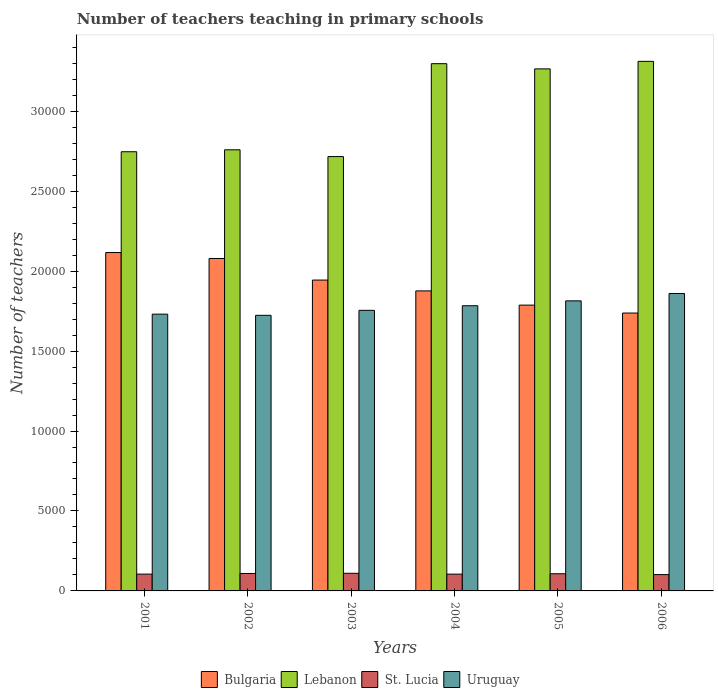How many different coloured bars are there?
Your answer should be compact. 4. Are the number of bars per tick equal to the number of legend labels?
Provide a succinct answer. Yes. In how many cases, is the number of bars for a given year not equal to the number of legend labels?
Provide a short and direct response. 0. What is the number of teachers teaching in primary schools in Lebanon in 2002?
Make the answer very short. 2.76e+04. Across all years, what is the maximum number of teachers teaching in primary schools in Lebanon?
Your response must be concise. 3.31e+04. Across all years, what is the minimum number of teachers teaching in primary schools in Bulgaria?
Your answer should be very brief. 1.74e+04. In which year was the number of teachers teaching in primary schools in St. Lucia minimum?
Keep it short and to the point. 2006. What is the total number of teachers teaching in primary schools in Uruguay in the graph?
Offer a very short reply. 1.07e+05. What is the difference between the number of teachers teaching in primary schools in Lebanon in 2003 and that in 2006?
Make the answer very short. -5954. What is the difference between the number of teachers teaching in primary schools in Bulgaria in 2005 and the number of teachers teaching in primary schools in St. Lucia in 2002?
Give a very brief answer. 1.68e+04. What is the average number of teachers teaching in primary schools in Bulgaria per year?
Your answer should be very brief. 1.92e+04. In the year 2006, what is the difference between the number of teachers teaching in primary schools in St. Lucia and number of teachers teaching in primary schools in Uruguay?
Your answer should be compact. -1.76e+04. In how many years, is the number of teachers teaching in primary schools in Uruguay greater than 29000?
Your answer should be compact. 0. What is the ratio of the number of teachers teaching in primary schools in St. Lucia in 2001 to that in 2003?
Your answer should be very brief. 0.95. Is the number of teachers teaching in primary schools in Bulgaria in 2004 less than that in 2005?
Your answer should be compact. No. Is the difference between the number of teachers teaching in primary schools in St. Lucia in 2003 and 2005 greater than the difference between the number of teachers teaching in primary schools in Uruguay in 2003 and 2005?
Offer a terse response. Yes. What is the difference between the highest and the second highest number of teachers teaching in primary schools in Bulgaria?
Your response must be concise. 372. Is the sum of the number of teachers teaching in primary schools in Lebanon in 2005 and 2006 greater than the maximum number of teachers teaching in primary schools in Bulgaria across all years?
Offer a terse response. Yes. Is it the case that in every year, the sum of the number of teachers teaching in primary schools in St. Lucia and number of teachers teaching in primary schools in Lebanon is greater than the sum of number of teachers teaching in primary schools in Uruguay and number of teachers teaching in primary schools in Bulgaria?
Your answer should be very brief. No. What does the 3rd bar from the left in 2002 represents?
Give a very brief answer. St. Lucia. What does the 2nd bar from the right in 2006 represents?
Make the answer very short. St. Lucia. Is it the case that in every year, the sum of the number of teachers teaching in primary schools in Bulgaria and number of teachers teaching in primary schools in Lebanon is greater than the number of teachers teaching in primary schools in Uruguay?
Keep it short and to the point. Yes. Are all the bars in the graph horizontal?
Offer a very short reply. No. What is the difference between two consecutive major ticks on the Y-axis?
Your answer should be compact. 5000. Does the graph contain any zero values?
Give a very brief answer. No. Where does the legend appear in the graph?
Make the answer very short. Bottom center. How many legend labels are there?
Offer a terse response. 4. How are the legend labels stacked?
Keep it short and to the point. Horizontal. What is the title of the graph?
Offer a very short reply. Number of teachers teaching in primary schools. What is the label or title of the X-axis?
Your response must be concise. Years. What is the label or title of the Y-axis?
Provide a succinct answer. Number of teachers. What is the Number of teachers of Bulgaria in 2001?
Your answer should be compact. 2.12e+04. What is the Number of teachers in Lebanon in 2001?
Your response must be concise. 2.75e+04. What is the Number of teachers in St. Lucia in 2001?
Your response must be concise. 1052. What is the Number of teachers in Uruguay in 2001?
Offer a very short reply. 1.73e+04. What is the Number of teachers in Bulgaria in 2002?
Give a very brief answer. 2.08e+04. What is the Number of teachers of Lebanon in 2002?
Offer a very short reply. 2.76e+04. What is the Number of teachers of St. Lucia in 2002?
Provide a short and direct response. 1091. What is the Number of teachers of Uruguay in 2002?
Offer a very short reply. 1.72e+04. What is the Number of teachers of Bulgaria in 2003?
Provide a short and direct response. 1.94e+04. What is the Number of teachers of Lebanon in 2003?
Keep it short and to the point. 2.72e+04. What is the Number of teachers in St. Lucia in 2003?
Ensure brevity in your answer.  1103. What is the Number of teachers in Uruguay in 2003?
Your answer should be very brief. 1.75e+04. What is the Number of teachers in Bulgaria in 2004?
Keep it short and to the point. 1.88e+04. What is the Number of teachers in Lebanon in 2004?
Offer a very short reply. 3.30e+04. What is the Number of teachers of St. Lucia in 2004?
Offer a very short reply. 1050. What is the Number of teachers of Uruguay in 2004?
Provide a short and direct response. 1.78e+04. What is the Number of teachers of Bulgaria in 2005?
Your answer should be very brief. 1.79e+04. What is the Number of teachers in Lebanon in 2005?
Your response must be concise. 3.26e+04. What is the Number of teachers of St. Lucia in 2005?
Offer a terse response. 1073. What is the Number of teachers in Uruguay in 2005?
Your answer should be compact. 1.81e+04. What is the Number of teachers in Bulgaria in 2006?
Make the answer very short. 1.74e+04. What is the Number of teachers in Lebanon in 2006?
Offer a very short reply. 3.31e+04. What is the Number of teachers of St. Lucia in 2006?
Provide a succinct answer. 1022. What is the Number of teachers of Uruguay in 2006?
Provide a succinct answer. 1.86e+04. Across all years, what is the maximum Number of teachers in Bulgaria?
Ensure brevity in your answer.  2.12e+04. Across all years, what is the maximum Number of teachers of Lebanon?
Ensure brevity in your answer.  3.31e+04. Across all years, what is the maximum Number of teachers of St. Lucia?
Give a very brief answer. 1103. Across all years, what is the maximum Number of teachers of Uruguay?
Keep it short and to the point. 1.86e+04. Across all years, what is the minimum Number of teachers in Bulgaria?
Your answer should be compact. 1.74e+04. Across all years, what is the minimum Number of teachers in Lebanon?
Provide a succinct answer. 2.72e+04. Across all years, what is the minimum Number of teachers of St. Lucia?
Provide a short and direct response. 1022. Across all years, what is the minimum Number of teachers of Uruguay?
Your answer should be very brief. 1.72e+04. What is the total Number of teachers of Bulgaria in the graph?
Keep it short and to the point. 1.15e+05. What is the total Number of teachers of Lebanon in the graph?
Offer a terse response. 1.81e+05. What is the total Number of teachers in St. Lucia in the graph?
Give a very brief answer. 6391. What is the total Number of teachers of Uruguay in the graph?
Make the answer very short. 1.07e+05. What is the difference between the Number of teachers in Bulgaria in 2001 and that in 2002?
Provide a succinct answer. 372. What is the difference between the Number of teachers of Lebanon in 2001 and that in 2002?
Offer a terse response. -122. What is the difference between the Number of teachers in St. Lucia in 2001 and that in 2002?
Give a very brief answer. -39. What is the difference between the Number of teachers of Bulgaria in 2001 and that in 2003?
Your response must be concise. 1722. What is the difference between the Number of teachers in Lebanon in 2001 and that in 2003?
Your answer should be very brief. 301. What is the difference between the Number of teachers in St. Lucia in 2001 and that in 2003?
Offer a very short reply. -51. What is the difference between the Number of teachers in Uruguay in 2001 and that in 2003?
Give a very brief answer. -240. What is the difference between the Number of teachers of Bulgaria in 2001 and that in 2004?
Make the answer very short. 2399. What is the difference between the Number of teachers in Lebanon in 2001 and that in 2004?
Offer a very short reply. -5508. What is the difference between the Number of teachers of Uruguay in 2001 and that in 2004?
Ensure brevity in your answer.  -527. What is the difference between the Number of teachers of Bulgaria in 2001 and that in 2005?
Provide a short and direct response. 3288. What is the difference between the Number of teachers in Lebanon in 2001 and that in 2005?
Your answer should be compact. -5182. What is the difference between the Number of teachers in St. Lucia in 2001 and that in 2005?
Give a very brief answer. -21. What is the difference between the Number of teachers in Uruguay in 2001 and that in 2005?
Your response must be concise. -832. What is the difference between the Number of teachers in Bulgaria in 2001 and that in 2006?
Your answer should be compact. 3783. What is the difference between the Number of teachers in Lebanon in 2001 and that in 2006?
Offer a very short reply. -5653. What is the difference between the Number of teachers in St. Lucia in 2001 and that in 2006?
Give a very brief answer. 30. What is the difference between the Number of teachers of Uruguay in 2001 and that in 2006?
Offer a terse response. -1293. What is the difference between the Number of teachers in Bulgaria in 2002 and that in 2003?
Offer a terse response. 1350. What is the difference between the Number of teachers in Lebanon in 2002 and that in 2003?
Your answer should be compact. 423. What is the difference between the Number of teachers in St. Lucia in 2002 and that in 2003?
Offer a terse response. -12. What is the difference between the Number of teachers of Uruguay in 2002 and that in 2003?
Offer a terse response. -312. What is the difference between the Number of teachers of Bulgaria in 2002 and that in 2004?
Offer a terse response. 2027. What is the difference between the Number of teachers of Lebanon in 2002 and that in 2004?
Your answer should be very brief. -5386. What is the difference between the Number of teachers of Uruguay in 2002 and that in 2004?
Offer a terse response. -599. What is the difference between the Number of teachers in Bulgaria in 2002 and that in 2005?
Your answer should be compact. 2916. What is the difference between the Number of teachers of Lebanon in 2002 and that in 2005?
Your response must be concise. -5060. What is the difference between the Number of teachers of Uruguay in 2002 and that in 2005?
Ensure brevity in your answer.  -904. What is the difference between the Number of teachers in Bulgaria in 2002 and that in 2006?
Offer a very short reply. 3411. What is the difference between the Number of teachers in Lebanon in 2002 and that in 2006?
Make the answer very short. -5531. What is the difference between the Number of teachers in St. Lucia in 2002 and that in 2006?
Your answer should be compact. 69. What is the difference between the Number of teachers in Uruguay in 2002 and that in 2006?
Your answer should be compact. -1365. What is the difference between the Number of teachers in Bulgaria in 2003 and that in 2004?
Keep it short and to the point. 677. What is the difference between the Number of teachers in Lebanon in 2003 and that in 2004?
Your response must be concise. -5809. What is the difference between the Number of teachers in St. Lucia in 2003 and that in 2004?
Provide a succinct answer. 53. What is the difference between the Number of teachers in Uruguay in 2003 and that in 2004?
Provide a short and direct response. -287. What is the difference between the Number of teachers of Bulgaria in 2003 and that in 2005?
Your response must be concise. 1566. What is the difference between the Number of teachers of Lebanon in 2003 and that in 2005?
Ensure brevity in your answer.  -5483. What is the difference between the Number of teachers in Uruguay in 2003 and that in 2005?
Provide a succinct answer. -592. What is the difference between the Number of teachers of Bulgaria in 2003 and that in 2006?
Your response must be concise. 2061. What is the difference between the Number of teachers in Lebanon in 2003 and that in 2006?
Offer a very short reply. -5954. What is the difference between the Number of teachers in St. Lucia in 2003 and that in 2006?
Make the answer very short. 81. What is the difference between the Number of teachers in Uruguay in 2003 and that in 2006?
Your response must be concise. -1053. What is the difference between the Number of teachers of Bulgaria in 2004 and that in 2005?
Offer a very short reply. 889. What is the difference between the Number of teachers in Lebanon in 2004 and that in 2005?
Offer a terse response. 326. What is the difference between the Number of teachers in St. Lucia in 2004 and that in 2005?
Offer a very short reply. -23. What is the difference between the Number of teachers in Uruguay in 2004 and that in 2005?
Ensure brevity in your answer.  -305. What is the difference between the Number of teachers in Bulgaria in 2004 and that in 2006?
Offer a very short reply. 1384. What is the difference between the Number of teachers of Lebanon in 2004 and that in 2006?
Your response must be concise. -145. What is the difference between the Number of teachers of Uruguay in 2004 and that in 2006?
Your answer should be very brief. -766. What is the difference between the Number of teachers in Bulgaria in 2005 and that in 2006?
Keep it short and to the point. 495. What is the difference between the Number of teachers in Lebanon in 2005 and that in 2006?
Provide a succinct answer. -471. What is the difference between the Number of teachers in St. Lucia in 2005 and that in 2006?
Ensure brevity in your answer.  51. What is the difference between the Number of teachers of Uruguay in 2005 and that in 2006?
Give a very brief answer. -461. What is the difference between the Number of teachers of Bulgaria in 2001 and the Number of teachers of Lebanon in 2002?
Make the answer very short. -6425. What is the difference between the Number of teachers in Bulgaria in 2001 and the Number of teachers in St. Lucia in 2002?
Provide a succinct answer. 2.01e+04. What is the difference between the Number of teachers in Bulgaria in 2001 and the Number of teachers in Uruguay in 2002?
Make the answer very short. 3926. What is the difference between the Number of teachers in Lebanon in 2001 and the Number of teachers in St. Lucia in 2002?
Your answer should be compact. 2.64e+04. What is the difference between the Number of teachers in Lebanon in 2001 and the Number of teachers in Uruguay in 2002?
Offer a very short reply. 1.02e+04. What is the difference between the Number of teachers of St. Lucia in 2001 and the Number of teachers of Uruguay in 2002?
Your answer should be very brief. -1.62e+04. What is the difference between the Number of teachers in Bulgaria in 2001 and the Number of teachers in Lebanon in 2003?
Provide a succinct answer. -6002. What is the difference between the Number of teachers in Bulgaria in 2001 and the Number of teachers in St. Lucia in 2003?
Your answer should be compact. 2.01e+04. What is the difference between the Number of teachers of Bulgaria in 2001 and the Number of teachers of Uruguay in 2003?
Your answer should be very brief. 3614. What is the difference between the Number of teachers in Lebanon in 2001 and the Number of teachers in St. Lucia in 2003?
Offer a terse response. 2.64e+04. What is the difference between the Number of teachers of Lebanon in 2001 and the Number of teachers of Uruguay in 2003?
Keep it short and to the point. 9917. What is the difference between the Number of teachers in St. Lucia in 2001 and the Number of teachers in Uruguay in 2003?
Your answer should be compact. -1.65e+04. What is the difference between the Number of teachers in Bulgaria in 2001 and the Number of teachers in Lebanon in 2004?
Your answer should be compact. -1.18e+04. What is the difference between the Number of teachers of Bulgaria in 2001 and the Number of teachers of St. Lucia in 2004?
Your answer should be very brief. 2.01e+04. What is the difference between the Number of teachers in Bulgaria in 2001 and the Number of teachers in Uruguay in 2004?
Your answer should be very brief. 3327. What is the difference between the Number of teachers of Lebanon in 2001 and the Number of teachers of St. Lucia in 2004?
Keep it short and to the point. 2.64e+04. What is the difference between the Number of teachers of Lebanon in 2001 and the Number of teachers of Uruguay in 2004?
Your response must be concise. 9630. What is the difference between the Number of teachers of St. Lucia in 2001 and the Number of teachers of Uruguay in 2004?
Give a very brief answer. -1.68e+04. What is the difference between the Number of teachers in Bulgaria in 2001 and the Number of teachers in Lebanon in 2005?
Provide a succinct answer. -1.15e+04. What is the difference between the Number of teachers in Bulgaria in 2001 and the Number of teachers in St. Lucia in 2005?
Your response must be concise. 2.01e+04. What is the difference between the Number of teachers of Bulgaria in 2001 and the Number of teachers of Uruguay in 2005?
Keep it short and to the point. 3022. What is the difference between the Number of teachers in Lebanon in 2001 and the Number of teachers in St. Lucia in 2005?
Provide a short and direct response. 2.64e+04. What is the difference between the Number of teachers in Lebanon in 2001 and the Number of teachers in Uruguay in 2005?
Make the answer very short. 9325. What is the difference between the Number of teachers in St. Lucia in 2001 and the Number of teachers in Uruguay in 2005?
Provide a succinct answer. -1.71e+04. What is the difference between the Number of teachers of Bulgaria in 2001 and the Number of teachers of Lebanon in 2006?
Provide a succinct answer. -1.20e+04. What is the difference between the Number of teachers of Bulgaria in 2001 and the Number of teachers of St. Lucia in 2006?
Make the answer very short. 2.01e+04. What is the difference between the Number of teachers of Bulgaria in 2001 and the Number of teachers of Uruguay in 2006?
Your answer should be compact. 2561. What is the difference between the Number of teachers of Lebanon in 2001 and the Number of teachers of St. Lucia in 2006?
Provide a short and direct response. 2.64e+04. What is the difference between the Number of teachers in Lebanon in 2001 and the Number of teachers in Uruguay in 2006?
Keep it short and to the point. 8864. What is the difference between the Number of teachers in St. Lucia in 2001 and the Number of teachers in Uruguay in 2006?
Provide a short and direct response. -1.75e+04. What is the difference between the Number of teachers in Bulgaria in 2002 and the Number of teachers in Lebanon in 2003?
Provide a succinct answer. -6374. What is the difference between the Number of teachers in Bulgaria in 2002 and the Number of teachers in St. Lucia in 2003?
Ensure brevity in your answer.  1.97e+04. What is the difference between the Number of teachers of Bulgaria in 2002 and the Number of teachers of Uruguay in 2003?
Keep it short and to the point. 3242. What is the difference between the Number of teachers in Lebanon in 2002 and the Number of teachers in St. Lucia in 2003?
Give a very brief answer. 2.65e+04. What is the difference between the Number of teachers in Lebanon in 2002 and the Number of teachers in Uruguay in 2003?
Offer a terse response. 1.00e+04. What is the difference between the Number of teachers in St. Lucia in 2002 and the Number of teachers in Uruguay in 2003?
Your answer should be compact. -1.65e+04. What is the difference between the Number of teachers of Bulgaria in 2002 and the Number of teachers of Lebanon in 2004?
Offer a terse response. -1.22e+04. What is the difference between the Number of teachers in Bulgaria in 2002 and the Number of teachers in St. Lucia in 2004?
Make the answer very short. 1.97e+04. What is the difference between the Number of teachers of Bulgaria in 2002 and the Number of teachers of Uruguay in 2004?
Provide a succinct answer. 2955. What is the difference between the Number of teachers of Lebanon in 2002 and the Number of teachers of St. Lucia in 2004?
Your answer should be very brief. 2.65e+04. What is the difference between the Number of teachers of Lebanon in 2002 and the Number of teachers of Uruguay in 2004?
Give a very brief answer. 9752. What is the difference between the Number of teachers of St. Lucia in 2002 and the Number of teachers of Uruguay in 2004?
Keep it short and to the point. -1.67e+04. What is the difference between the Number of teachers in Bulgaria in 2002 and the Number of teachers in Lebanon in 2005?
Keep it short and to the point. -1.19e+04. What is the difference between the Number of teachers in Bulgaria in 2002 and the Number of teachers in St. Lucia in 2005?
Provide a succinct answer. 1.97e+04. What is the difference between the Number of teachers of Bulgaria in 2002 and the Number of teachers of Uruguay in 2005?
Your answer should be very brief. 2650. What is the difference between the Number of teachers in Lebanon in 2002 and the Number of teachers in St. Lucia in 2005?
Offer a terse response. 2.65e+04. What is the difference between the Number of teachers in Lebanon in 2002 and the Number of teachers in Uruguay in 2005?
Provide a succinct answer. 9447. What is the difference between the Number of teachers of St. Lucia in 2002 and the Number of teachers of Uruguay in 2005?
Provide a short and direct response. -1.70e+04. What is the difference between the Number of teachers in Bulgaria in 2002 and the Number of teachers in Lebanon in 2006?
Ensure brevity in your answer.  -1.23e+04. What is the difference between the Number of teachers of Bulgaria in 2002 and the Number of teachers of St. Lucia in 2006?
Offer a very short reply. 1.98e+04. What is the difference between the Number of teachers of Bulgaria in 2002 and the Number of teachers of Uruguay in 2006?
Offer a terse response. 2189. What is the difference between the Number of teachers of Lebanon in 2002 and the Number of teachers of St. Lucia in 2006?
Give a very brief answer. 2.66e+04. What is the difference between the Number of teachers in Lebanon in 2002 and the Number of teachers in Uruguay in 2006?
Your answer should be very brief. 8986. What is the difference between the Number of teachers of St. Lucia in 2002 and the Number of teachers of Uruguay in 2006?
Ensure brevity in your answer.  -1.75e+04. What is the difference between the Number of teachers in Bulgaria in 2003 and the Number of teachers in Lebanon in 2004?
Provide a short and direct response. -1.35e+04. What is the difference between the Number of teachers of Bulgaria in 2003 and the Number of teachers of St. Lucia in 2004?
Provide a succinct answer. 1.84e+04. What is the difference between the Number of teachers in Bulgaria in 2003 and the Number of teachers in Uruguay in 2004?
Your response must be concise. 1605. What is the difference between the Number of teachers of Lebanon in 2003 and the Number of teachers of St. Lucia in 2004?
Give a very brief answer. 2.61e+04. What is the difference between the Number of teachers of Lebanon in 2003 and the Number of teachers of Uruguay in 2004?
Give a very brief answer. 9329. What is the difference between the Number of teachers in St. Lucia in 2003 and the Number of teachers in Uruguay in 2004?
Your answer should be very brief. -1.67e+04. What is the difference between the Number of teachers of Bulgaria in 2003 and the Number of teachers of Lebanon in 2005?
Give a very brief answer. -1.32e+04. What is the difference between the Number of teachers in Bulgaria in 2003 and the Number of teachers in St. Lucia in 2005?
Offer a very short reply. 1.84e+04. What is the difference between the Number of teachers of Bulgaria in 2003 and the Number of teachers of Uruguay in 2005?
Provide a short and direct response. 1300. What is the difference between the Number of teachers of Lebanon in 2003 and the Number of teachers of St. Lucia in 2005?
Offer a very short reply. 2.61e+04. What is the difference between the Number of teachers of Lebanon in 2003 and the Number of teachers of Uruguay in 2005?
Provide a succinct answer. 9024. What is the difference between the Number of teachers in St. Lucia in 2003 and the Number of teachers in Uruguay in 2005?
Offer a terse response. -1.70e+04. What is the difference between the Number of teachers in Bulgaria in 2003 and the Number of teachers in Lebanon in 2006?
Provide a succinct answer. -1.37e+04. What is the difference between the Number of teachers in Bulgaria in 2003 and the Number of teachers in St. Lucia in 2006?
Your answer should be very brief. 1.84e+04. What is the difference between the Number of teachers in Bulgaria in 2003 and the Number of teachers in Uruguay in 2006?
Make the answer very short. 839. What is the difference between the Number of teachers of Lebanon in 2003 and the Number of teachers of St. Lucia in 2006?
Your response must be concise. 2.61e+04. What is the difference between the Number of teachers in Lebanon in 2003 and the Number of teachers in Uruguay in 2006?
Your answer should be compact. 8563. What is the difference between the Number of teachers in St. Lucia in 2003 and the Number of teachers in Uruguay in 2006?
Your response must be concise. -1.75e+04. What is the difference between the Number of teachers of Bulgaria in 2004 and the Number of teachers of Lebanon in 2005?
Make the answer very short. -1.39e+04. What is the difference between the Number of teachers of Bulgaria in 2004 and the Number of teachers of St. Lucia in 2005?
Offer a terse response. 1.77e+04. What is the difference between the Number of teachers of Bulgaria in 2004 and the Number of teachers of Uruguay in 2005?
Your answer should be very brief. 623. What is the difference between the Number of teachers of Lebanon in 2004 and the Number of teachers of St. Lucia in 2005?
Provide a succinct answer. 3.19e+04. What is the difference between the Number of teachers of Lebanon in 2004 and the Number of teachers of Uruguay in 2005?
Offer a very short reply. 1.48e+04. What is the difference between the Number of teachers in St. Lucia in 2004 and the Number of teachers in Uruguay in 2005?
Offer a very short reply. -1.71e+04. What is the difference between the Number of teachers in Bulgaria in 2004 and the Number of teachers in Lebanon in 2006?
Your answer should be very brief. -1.44e+04. What is the difference between the Number of teachers in Bulgaria in 2004 and the Number of teachers in St. Lucia in 2006?
Your response must be concise. 1.77e+04. What is the difference between the Number of teachers of Bulgaria in 2004 and the Number of teachers of Uruguay in 2006?
Make the answer very short. 162. What is the difference between the Number of teachers of Lebanon in 2004 and the Number of teachers of St. Lucia in 2006?
Keep it short and to the point. 3.20e+04. What is the difference between the Number of teachers of Lebanon in 2004 and the Number of teachers of Uruguay in 2006?
Offer a very short reply. 1.44e+04. What is the difference between the Number of teachers in St. Lucia in 2004 and the Number of teachers in Uruguay in 2006?
Keep it short and to the point. -1.76e+04. What is the difference between the Number of teachers in Bulgaria in 2005 and the Number of teachers in Lebanon in 2006?
Offer a very short reply. -1.52e+04. What is the difference between the Number of teachers in Bulgaria in 2005 and the Number of teachers in St. Lucia in 2006?
Your answer should be compact. 1.69e+04. What is the difference between the Number of teachers in Bulgaria in 2005 and the Number of teachers in Uruguay in 2006?
Provide a succinct answer. -727. What is the difference between the Number of teachers of Lebanon in 2005 and the Number of teachers of St. Lucia in 2006?
Offer a very short reply. 3.16e+04. What is the difference between the Number of teachers in Lebanon in 2005 and the Number of teachers in Uruguay in 2006?
Keep it short and to the point. 1.40e+04. What is the difference between the Number of teachers of St. Lucia in 2005 and the Number of teachers of Uruguay in 2006?
Provide a short and direct response. -1.75e+04. What is the average Number of teachers in Bulgaria per year?
Your answer should be compact. 1.92e+04. What is the average Number of teachers in Lebanon per year?
Your answer should be compact. 3.02e+04. What is the average Number of teachers in St. Lucia per year?
Your answer should be very brief. 1065.17. What is the average Number of teachers in Uruguay per year?
Provide a succinct answer. 1.78e+04. In the year 2001, what is the difference between the Number of teachers in Bulgaria and Number of teachers in Lebanon?
Offer a terse response. -6303. In the year 2001, what is the difference between the Number of teachers of Bulgaria and Number of teachers of St. Lucia?
Provide a short and direct response. 2.01e+04. In the year 2001, what is the difference between the Number of teachers in Bulgaria and Number of teachers in Uruguay?
Offer a very short reply. 3854. In the year 2001, what is the difference between the Number of teachers in Lebanon and Number of teachers in St. Lucia?
Provide a succinct answer. 2.64e+04. In the year 2001, what is the difference between the Number of teachers of Lebanon and Number of teachers of Uruguay?
Give a very brief answer. 1.02e+04. In the year 2001, what is the difference between the Number of teachers in St. Lucia and Number of teachers in Uruguay?
Ensure brevity in your answer.  -1.63e+04. In the year 2002, what is the difference between the Number of teachers in Bulgaria and Number of teachers in Lebanon?
Give a very brief answer. -6797. In the year 2002, what is the difference between the Number of teachers in Bulgaria and Number of teachers in St. Lucia?
Your response must be concise. 1.97e+04. In the year 2002, what is the difference between the Number of teachers of Bulgaria and Number of teachers of Uruguay?
Your response must be concise. 3554. In the year 2002, what is the difference between the Number of teachers in Lebanon and Number of teachers in St. Lucia?
Offer a terse response. 2.65e+04. In the year 2002, what is the difference between the Number of teachers in Lebanon and Number of teachers in Uruguay?
Offer a terse response. 1.04e+04. In the year 2002, what is the difference between the Number of teachers of St. Lucia and Number of teachers of Uruguay?
Your answer should be very brief. -1.61e+04. In the year 2003, what is the difference between the Number of teachers in Bulgaria and Number of teachers in Lebanon?
Make the answer very short. -7724. In the year 2003, what is the difference between the Number of teachers of Bulgaria and Number of teachers of St. Lucia?
Ensure brevity in your answer.  1.83e+04. In the year 2003, what is the difference between the Number of teachers of Bulgaria and Number of teachers of Uruguay?
Offer a terse response. 1892. In the year 2003, what is the difference between the Number of teachers in Lebanon and Number of teachers in St. Lucia?
Provide a short and direct response. 2.61e+04. In the year 2003, what is the difference between the Number of teachers in Lebanon and Number of teachers in Uruguay?
Provide a short and direct response. 9616. In the year 2003, what is the difference between the Number of teachers in St. Lucia and Number of teachers in Uruguay?
Ensure brevity in your answer.  -1.64e+04. In the year 2004, what is the difference between the Number of teachers of Bulgaria and Number of teachers of Lebanon?
Make the answer very short. -1.42e+04. In the year 2004, what is the difference between the Number of teachers of Bulgaria and Number of teachers of St. Lucia?
Ensure brevity in your answer.  1.77e+04. In the year 2004, what is the difference between the Number of teachers of Bulgaria and Number of teachers of Uruguay?
Provide a short and direct response. 928. In the year 2004, what is the difference between the Number of teachers in Lebanon and Number of teachers in St. Lucia?
Keep it short and to the point. 3.19e+04. In the year 2004, what is the difference between the Number of teachers of Lebanon and Number of teachers of Uruguay?
Make the answer very short. 1.51e+04. In the year 2004, what is the difference between the Number of teachers in St. Lucia and Number of teachers in Uruguay?
Offer a very short reply. -1.68e+04. In the year 2005, what is the difference between the Number of teachers of Bulgaria and Number of teachers of Lebanon?
Give a very brief answer. -1.48e+04. In the year 2005, what is the difference between the Number of teachers in Bulgaria and Number of teachers in St. Lucia?
Offer a terse response. 1.68e+04. In the year 2005, what is the difference between the Number of teachers in Bulgaria and Number of teachers in Uruguay?
Your answer should be very brief. -266. In the year 2005, what is the difference between the Number of teachers of Lebanon and Number of teachers of St. Lucia?
Provide a short and direct response. 3.16e+04. In the year 2005, what is the difference between the Number of teachers in Lebanon and Number of teachers in Uruguay?
Make the answer very short. 1.45e+04. In the year 2005, what is the difference between the Number of teachers of St. Lucia and Number of teachers of Uruguay?
Give a very brief answer. -1.71e+04. In the year 2006, what is the difference between the Number of teachers of Bulgaria and Number of teachers of Lebanon?
Provide a succinct answer. -1.57e+04. In the year 2006, what is the difference between the Number of teachers of Bulgaria and Number of teachers of St. Lucia?
Give a very brief answer. 1.64e+04. In the year 2006, what is the difference between the Number of teachers of Bulgaria and Number of teachers of Uruguay?
Give a very brief answer. -1222. In the year 2006, what is the difference between the Number of teachers in Lebanon and Number of teachers in St. Lucia?
Offer a terse response. 3.21e+04. In the year 2006, what is the difference between the Number of teachers in Lebanon and Number of teachers in Uruguay?
Offer a terse response. 1.45e+04. In the year 2006, what is the difference between the Number of teachers in St. Lucia and Number of teachers in Uruguay?
Make the answer very short. -1.76e+04. What is the ratio of the Number of teachers in Bulgaria in 2001 to that in 2002?
Ensure brevity in your answer.  1.02. What is the ratio of the Number of teachers of St. Lucia in 2001 to that in 2002?
Ensure brevity in your answer.  0.96. What is the ratio of the Number of teachers in Uruguay in 2001 to that in 2002?
Provide a succinct answer. 1. What is the ratio of the Number of teachers in Bulgaria in 2001 to that in 2003?
Make the answer very short. 1.09. What is the ratio of the Number of teachers of Lebanon in 2001 to that in 2003?
Make the answer very short. 1.01. What is the ratio of the Number of teachers in St. Lucia in 2001 to that in 2003?
Provide a succinct answer. 0.95. What is the ratio of the Number of teachers of Uruguay in 2001 to that in 2003?
Your response must be concise. 0.99. What is the ratio of the Number of teachers of Bulgaria in 2001 to that in 2004?
Ensure brevity in your answer.  1.13. What is the ratio of the Number of teachers in Lebanon in 2001 to that in 2004?
Your answer should be very brief. 0.83. What is the ratio of the Number of teachers in St. Lucia in 2001 to that in 2004?
Give a very brief answer. 1. What is the ratio of the Number of teachers in Uruguay in 2001 to that in 2004?
Offer a terse response. 0.97. What is the ratio of the Number of teachers in Bulgaria in 2001 to that in 2005?
Your answer should be compact. 1.18. What is the ratio of the Number of teachers of Lebanon in 2001 to that in 2005?
Offer a terse response. 0.84. What is the ratio of the Number of teachers in St. Lucia in 2001 to that in 2005?
Give a very brief answer. 0.98. What is the ratio of the Number of teachers in Uruguay in 2001 to that in 2005?
Ensure brevity in your answer.  0.95. What is the ratio of the Number of teachers in Bulgaria in 2001 to that in 2006?
Provide a succinct answer. 1.22. What is the ratio of the Number of teachers of Lebanon in 2001 to that in 2006?
Offer a very short reply. 0.83. What is the ratio of the Number of teachers of St. Lucia in 2001 to that in 2006?
Provide a short and direct response. 1.03. What is the ratio of the Number of teachers of Uruguay in 2001 to that in 2006?
Keep it short and to the point. 0.93. What is the ratio of the Number of teachers of Bulgaria in 2002 to that in 2003?
Offer a very short reply. 1.07. What is the ratio of the Number of teachers of Lebanon in 2002 to that in 2003?
Offer a terse response. 1.02. What is the ratio of the Number of teachers in Uruguay in 2002 to that in 2003?
Make the answer very short. 0.98. What is the ratio of the Number of teachers of Bulgaria in 2002 to that in 2004?
Ensure brevity in your answer.  1.11. What is the ratio of the Number of teachers in Lebanon in 2002 to that in 2004?
Give a very brief answer. 0.84. What is the ratio of the Number of teachers of St. Lucia in 2002 to that in 2004?
Keep it short and to the point. 1.04. What is the ratio of the Number of teachers in Uruguay in 2002 to that in 2004?
Offer a very short reply. 0.97. What is the ratio of the Number of teachers in Bulgaria in 2002 to that in 2005?
Provide a succinct answer. 1.16. What is the ratio of the Number of teachers in Lebanon in 2002 to that in 2005?
Ensure brevity in your answer.  0.84. What is the ratio of the Number of teachers of St. Lucia in 2002 to that in 2005?
Make the answer very short. 1.02. What is the ratio of the Number of teachers in Uruguay in 2002 to that in 2005?
Provide a succinct answer. 0.95. What is the ratio of the Number of teachers of Bulgaria in 2002 to that in 2006?
Give a very brief answer. 1.2. What is the ratio of the Number of teachers in Lebanon in 2002 to that in 2006?
Give a very brief answer. 0.83. What is the ratio of the Number of teachers of St. Lucia in 2002 to that in 2006?
Provide a short and direct response. 1.07. What is the ratio of the Number of teachers in Uruguay in 2002 to that in 2006?
Ensure brevity in your answer.  0.93. What is the ratio of the Number of teachers of Bulgaria in 2003 to that in 2004?
Keep it short and to the point. 1.04. What is the ratio of the Number of teachers of Lebanon in 2003 to that in 2004?
Provide a short and direct response. 0.82. What is the ratio of the Number of teachers in St. Lucia in 2003 to that in 2004?
Offer a very short reply. 1.05. What is the ratio of the Number of teachers of Uruguay in 2003 to that in 2004?
Offer a terse response. 0.98. What is the ratio of the Number of teachers of Bulgaria in 2003 to that in 2005?
Make the answer very short. 1.09. What is the ratio of the Number of teachers of Lebanon in 2003 to that in 2005?
Give a very brief answer. 0.83. What is the ratio of the Number of teachers of St. Lucia in 2003 to that in 2005?
Make the answer very short. 1.03. What is the ratio of the Number of teachers of Uruguay in 2003 to that in 2005?
Ensure brevity in your answer.  0.97. What is the ratio of the Number of teachers of Bulgaria in 2003 to that in 2006?
Keep it short and to the point. 1.12. What is the ratio of the Number of teachers in Lebanon in 2003 to that in 2006?
Offer a very short reply. 0.82. What is the ratio of the Number of teachers of St. Lucia in 2003 to that in 2006?
Provide a short and direct response. 1.08. What is the ratio of the Number of teachers in Uruguay in 2003 to that in 2006?
Provide a succinct answer. 0.94. What is the ratio of the Number of teachers of Bulgaria in 2004 to that in 2005?
Make the answer very short. 1.05. What is the ratio of the Number of teachers of St. Lucia in 2004 to that in 2005?
Provide a succinct answer. 0.98. What is the ratio of the Number of teachers of Uruguay in 2004 to that in 2005?
Your response must be concise. 0.98. What is the ratio of the Number of teachers in Bulgaria in 2004 to that in 2006?
Your response must be concise. 1.08. What is the ratio of the Number of teachers in Lebanon in 2004 to that in 2006?
Provide a short and direct response. 1. What is the ratio of the Number of teachers in St. Lucia in 2004 to that in 2006?
Provide a short and direct response. 1.03. What is the ratio of the Number of teachers of Uruguay in 2004 to that in 2006?
Ensure brevity in your answer.  0.96. What is the ratio of the Number of teachers in Bulgaria in 2005 to that in 2006?
Keep it short and to the point. 1.03. What is the ratio of the Number of teachers in Lebanon in 2005 to that in 2006?
Provide a short and direct response. 0.99. What is the ratio of the Number of teachers in St. Lucia in 2005 to that in 2006?
Give a very brief answer. 1.05. What is the ratio of the Number of teachers of Uruguay in 2005 to that in 2006?
Your answer should be very brief. 0.98. What is the difference between the highest and the second highest Number of teachers in Bulgaria?
Offer a terse response. 372. What is the difference between the highest and the second highest Number of teachers in Lebanon?
Give a very brief answer. 145. What is the difference between the highest and the second highest Number of teachers of St. Lucia?
Give a very brief answer. 12. What is the difference between the highest and the second highest Number of teachers of Uruguay?
Your response must be concise. 461. What is the difference between the highest and the lowest Number of teachers of Bulgaria?
Keep it short and to the point. 3783. What is the difference between the highest and the lowest Number of teachers in Lebanon?
Offer a very short reply. 5954. What is the difference between the highest and the lowest Number of teachers in Uruguay?
Make the answer very short. 1365. 